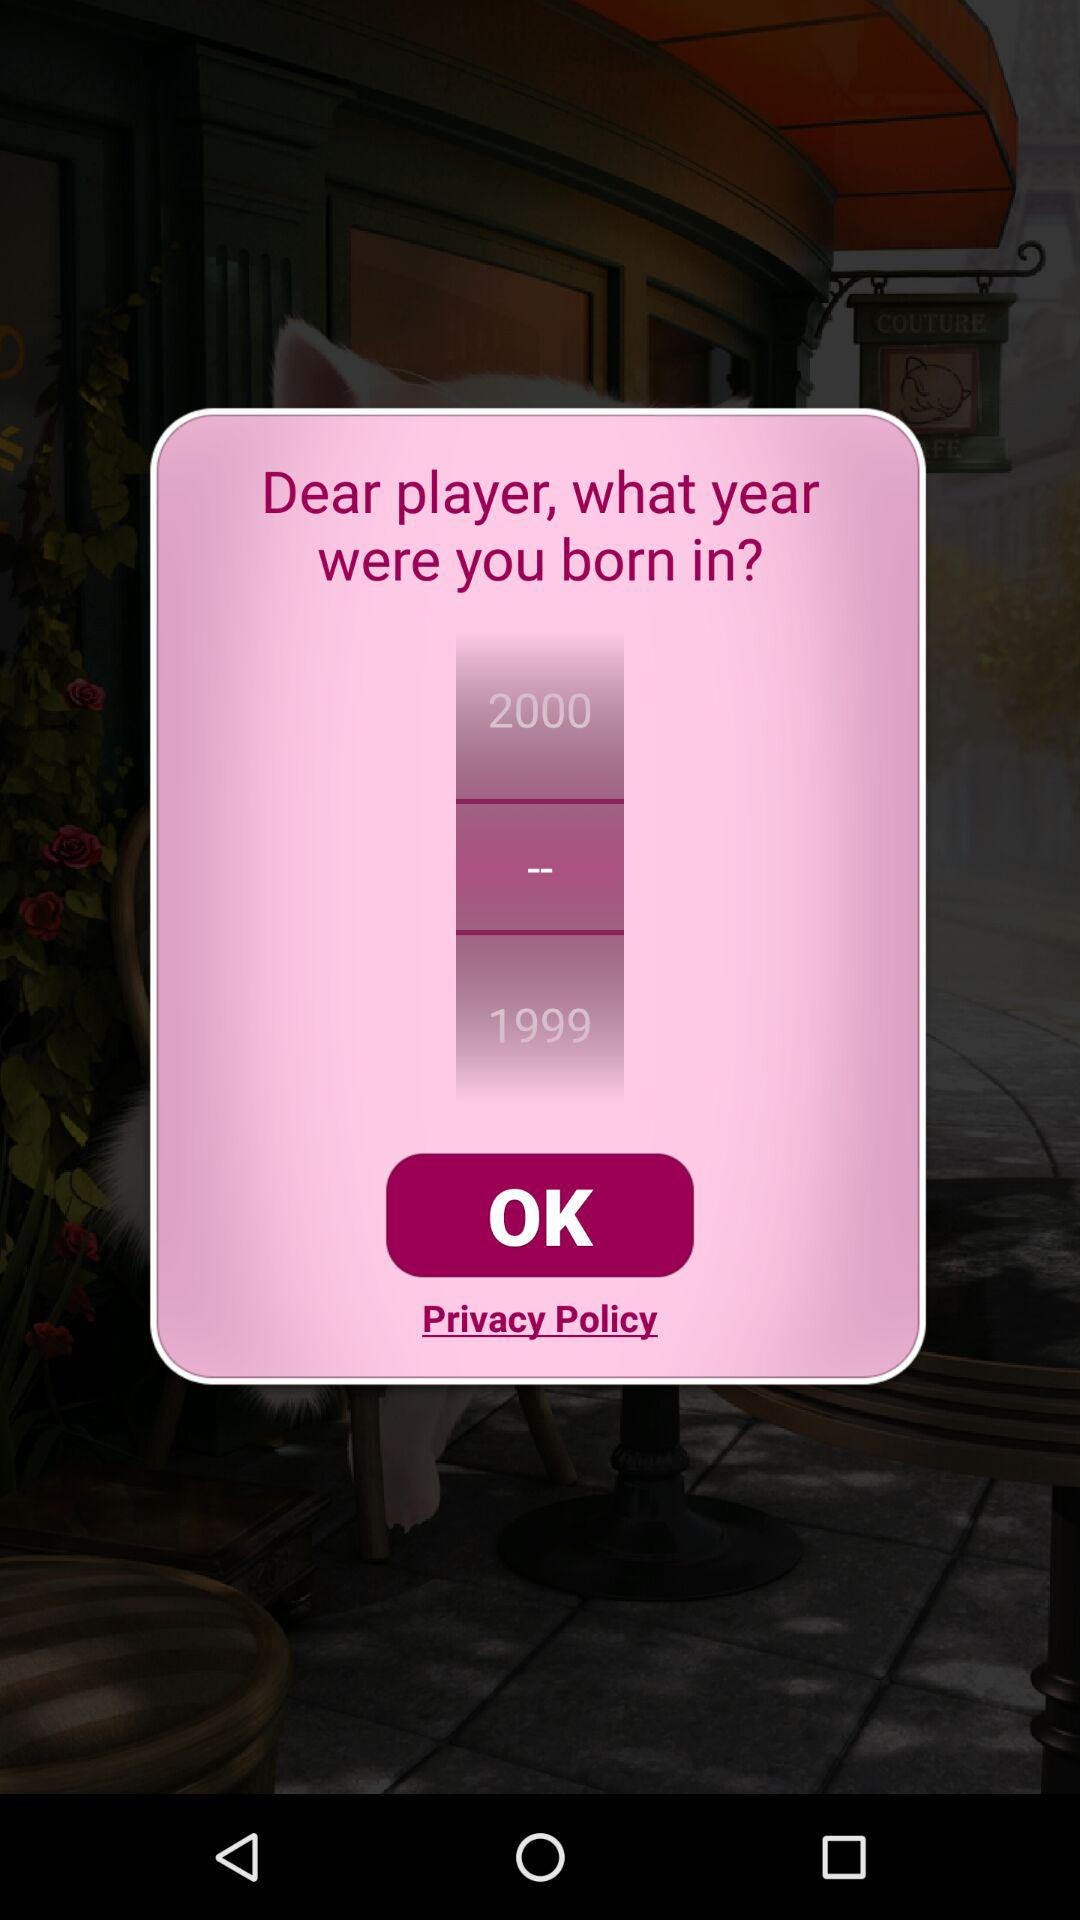What is the difference between the two years displayed on the screen?
Answer the question using a single word or phrase. 1 